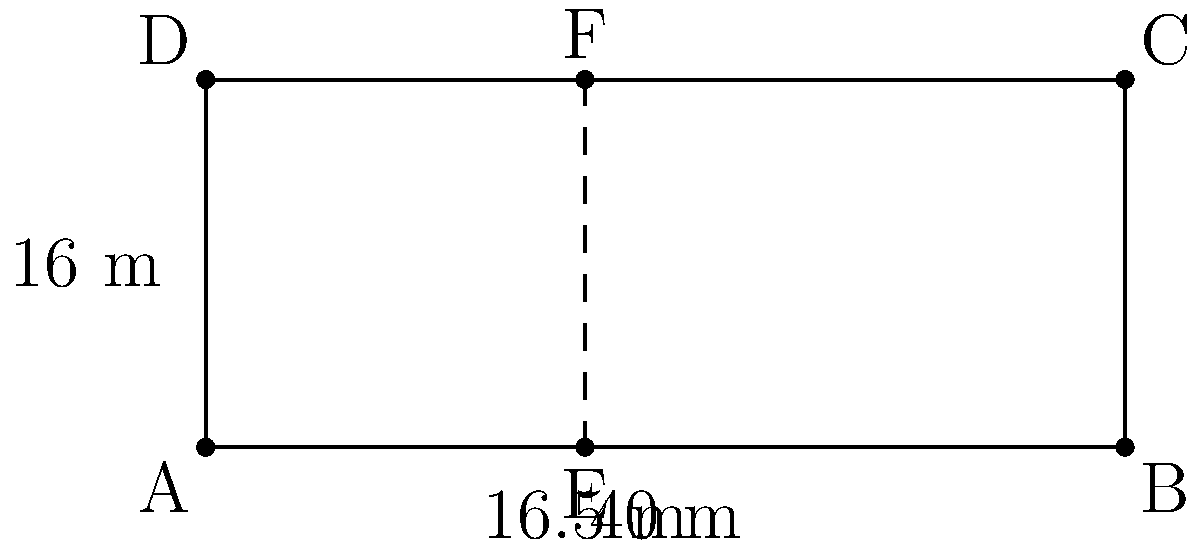As a devoted Jack Grealish fan, you're analyzing the penalty box dimensions at the Etihad Stadium. The penalty area is rectangular, measuring 40 meters wide and 16 meters deep. If a line is drawn parallel to the goal line at 16.5 meters from it, what is the difference in area between the two sections of the penalty box created by this line? Let's approach this step-by-step:

1) First, we need to calculate the total area of the penalty box:
   Area = width × depth
   $A_{total} = 40 \text{ m} \times 16 \text{ m} = 640 \text{ m}^2$

2) Now, we need to find the areas of the two sections:

   Section 1 (closer to the goal line):
   $A_1 = 40 \text{ m} \times 16.5 \text{ m} = 660 \text{ m}^2$

   Section 2 (farther from the goal line):
   $A_2 = 40 \text{ m} \times (16 \text{ m} - 16.5 \text{ m}) = 40 \text{ m} \times (-0.5 \text{ m}) = -20 \text{ m}^2$

3) The difference in area is the absolute value of the difference between these two sections:

   $\text{Difference} = |A_1 - A_2| = |660 \text{ m}^2 - (-20 \text{ m}^2)| = |680 \text{ m}^2| = 680 \text{ m}^2$

Therefore, the difference in area between the two sections is 680 square meters.
Answer: 680 m² 